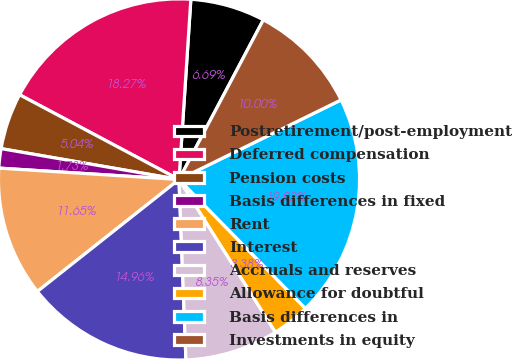Convert chart to OTSL. <chart><loc_0><loc_0><loc_500><loc_500><pie_chart><fcel>Postretirement/post-employment<fcel>Deferred compensation<fcel>Pension costs<fcel>Basis differences in fixed<fcel>Rent<fcel>Interest<fcel>Accruals and reserves<fcel>Allowance for doubtful<fcel>Basis differences in<fcel>Investments in equity<nl><fcel>6.69%<fcel>18.27%<fcel>5.04%<fcel>1.73%<fcel>11.65%<fcel>14.96%<fcel>8.35%<fcel>3.38%<fcel>19.92%<fcel>10.0%<nl></chart> 